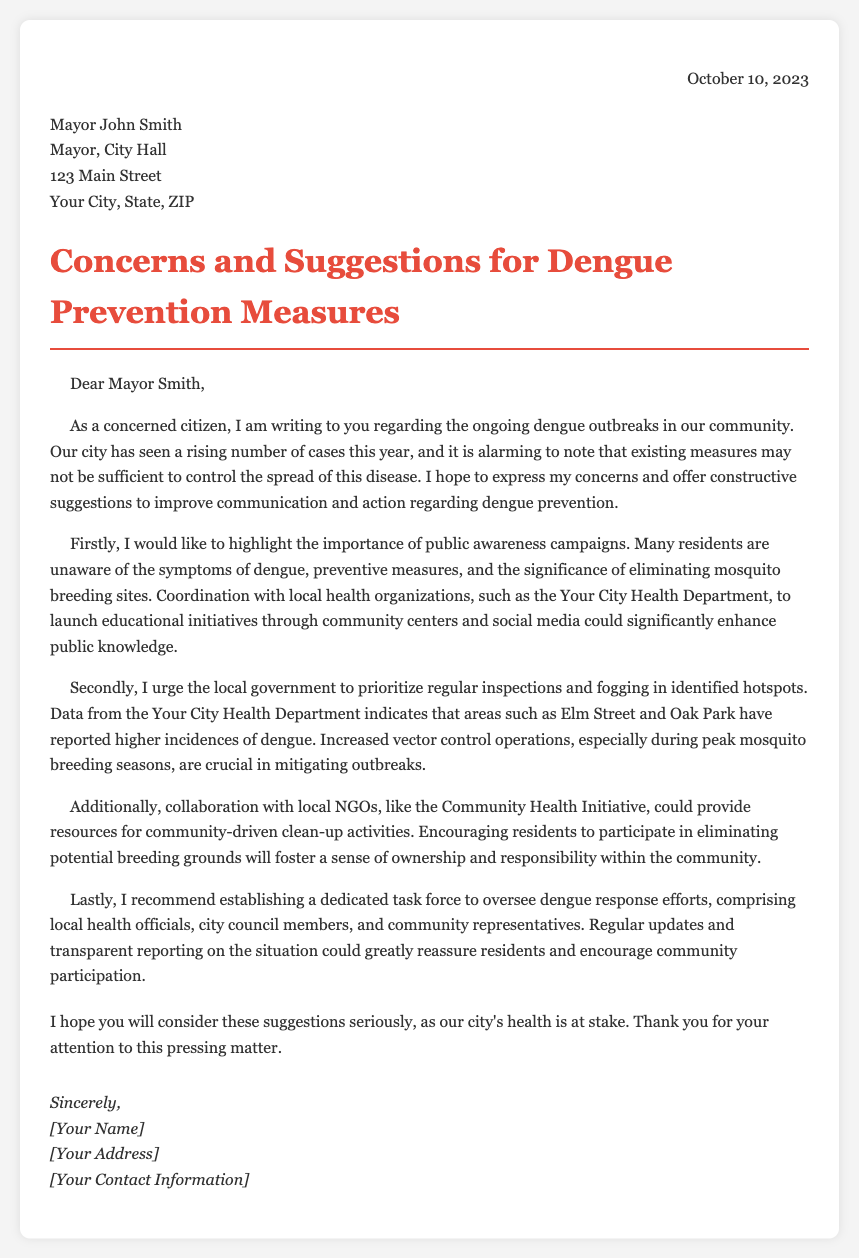What is the date of the letter? The letter was written on October 10, 2023.
Answer: October 10, 2023 Who is the recipient of the letter? The letter is addressed to Mayor John Smith.
Answer: Mayor John Smith What is the main concern expressed in the letter? The letter discusses rising dengue cases and insufficient prevention measures.
Answer: Rising dengue cases Which areas are mentioned as dengue hotspots? The letter specifies Elm Street and Oak Park as areas with higher incidences.
Answer: Elm Street and Oak Park What is one suggested action for public awareness? The letter suggests launching educational initiatives through community centers and social media.
Answer: Educational initiatives What is recommended to oversee dengue response efforts? The letter recommends establishing a dedicated task force.
Answer: Dedicated task force Which local organization is mentioned for potential collaboration? The letter mentions the Community Health Initiative for collaboration.
Answer: Community Health Initiative What is the tone of the letter? The letter expresses concerns while also providing constructive suggestions.
Answer: Constructive suggestions 